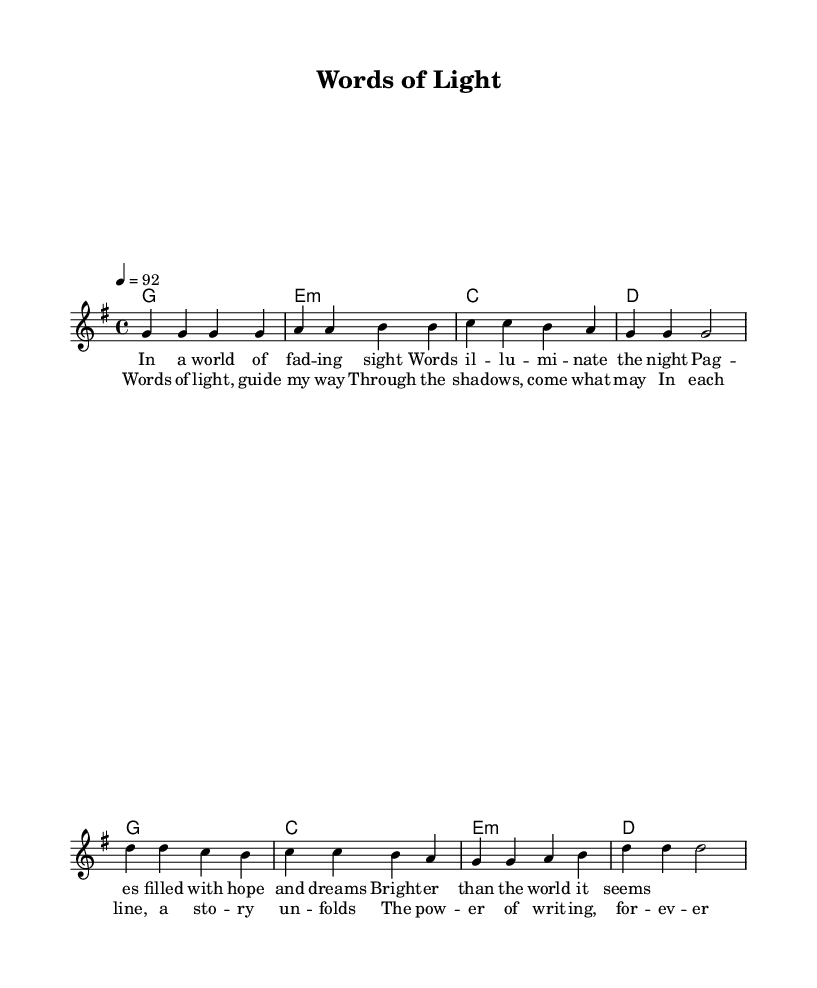What is the key signature of this music? The key signature is G major, which has one sharp (F#). This can be identified by looking at the key signature indicated at the beginning of the score next to the clef.
Answer: G major What is the time signature of this piece? The time signature is 4/4, which indicates there are four beats in each measure and the quarter note receives one beat. This is visible at the start of the score, indicating the rhythmic structure.
Answer: 4/4 What is the tempo marking given in the score? The tempo marking is 92 beats per minute, as specified in the score where it states “\tempo 4 = 92.” This indicates the speed of the performance.
Answer: 92 How many measures are in the verse? The verse consists of four measures, as can be counted in the melody section from the beginning until it transitions to the chorus. Each line corresponds to one measure.
Answer: Four Which chord follows the G chord in the verse? The chord that follows the G major chord in the verse is E minor, as indicated in the harmonies section of the score, showing a sequential relationship between the chords.
Answer: E minor What is the main theme of the chorus lyrics? The main theme of the chorus lyrics is about guidance and the power of words. This can be deduced from phrases like "Words of light, guide my way" which emphasizes the uplifting nature of the message.
Answer: Guidance What type of musical work is this piece? This piece is a reggae anthem that celebrates the power of the written word. The lyrical and harmonic structure, along with the upbeat tempo, are characteristic of uplifting reggae music.
Answer: Reggae anthem 